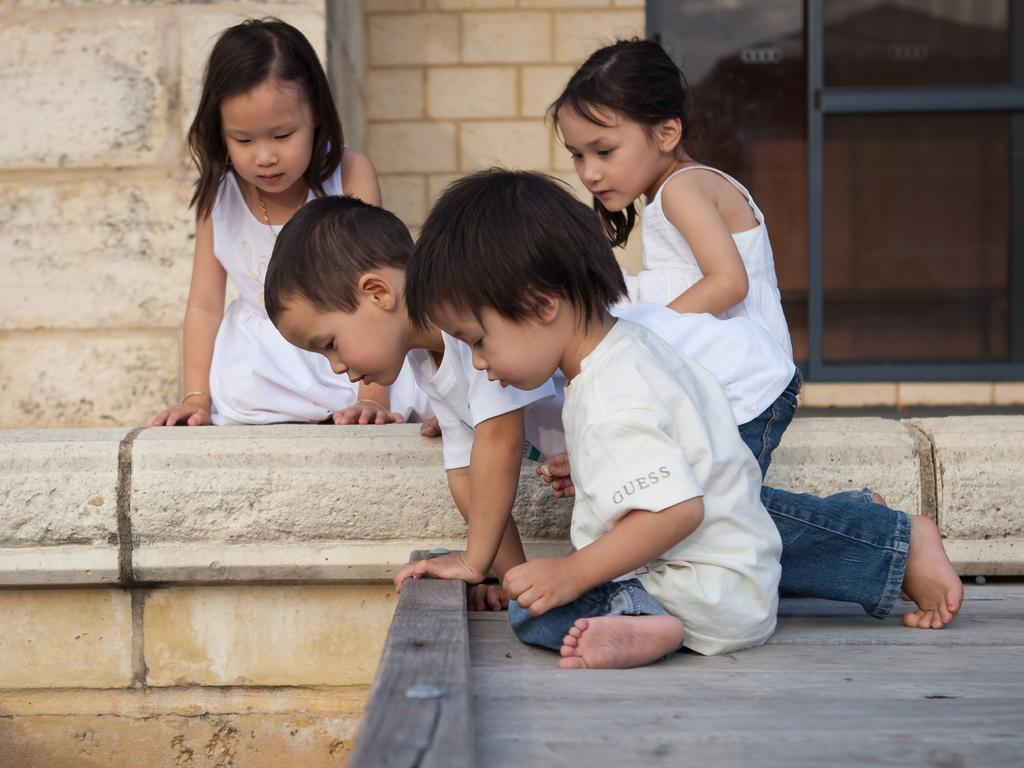How many people are present in the image? There are four people in the image. What can be seen in the background of the image? There is a wall and a window in the background of the image. What type of wing is visible on the people in the image? There are no wings visible on the people in the image. What branch of the military are the people in the image associated with? The image does not provide any information about the people's military affiliation. 